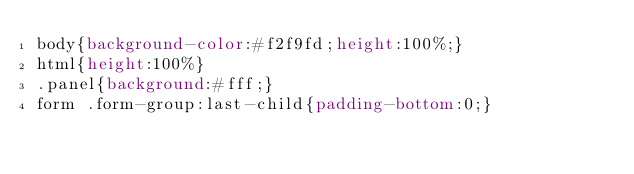<code> <loc_0><loc_0><loc_500><loc_500><_CSS_>body{background-color:#f2f9fd;height:100%;}
html{height:100%}
.panel{background:#fff;}
form .form-group:last-child{padding-bottom:0;}</code> 